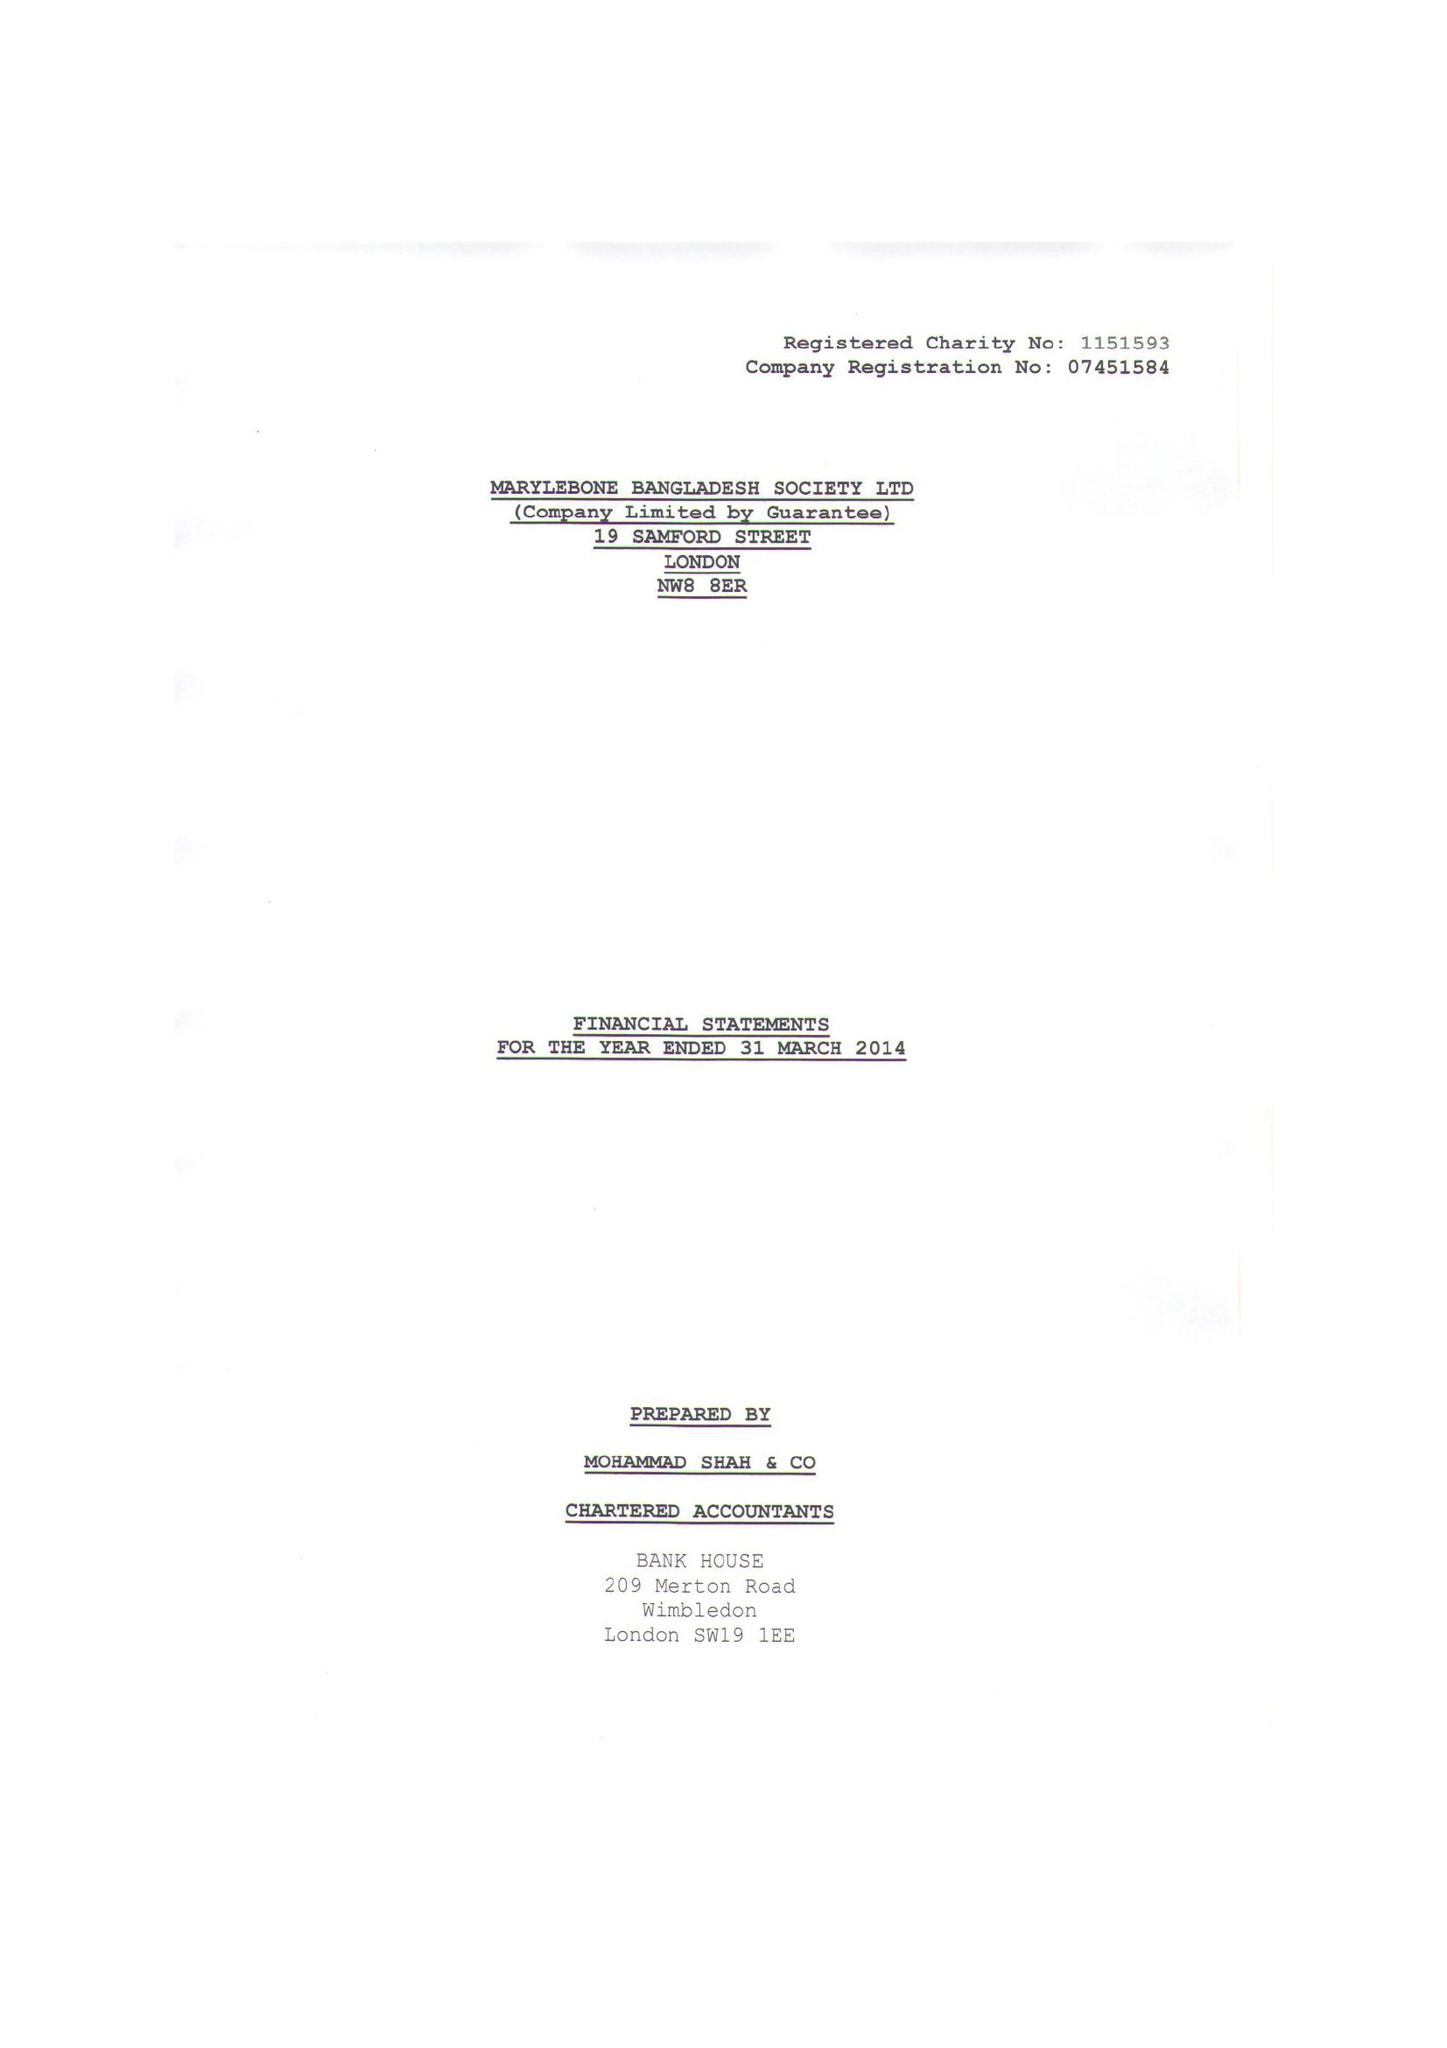What is the value for the address__postcode?
Answer the question using a single word or phrase. NW8 8ER 